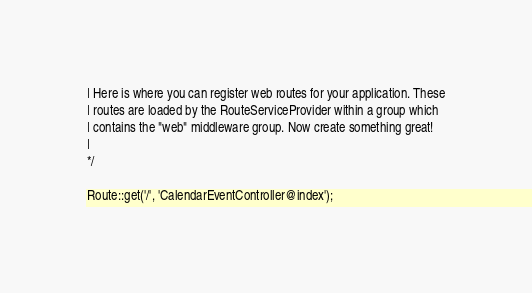Convert code to text. <code><loc_0><loc_0><loc_500><loc_500><_PHP_>| Here is where you can register web routes for your application. These
| routes are loaded by the RouteServiceProvider within a group which
| contains the "web" middleware group. Now create something great!
|
*/

Route::get('/', 'CalendarEventController@index');
</code> 